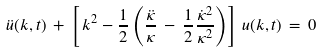Convert formula to latex. <formula><loc_0><loc_0><loc_500><loc_500>\ddot { u } ( k , t ) \, + \, \left [ \, k ^ { 2 } - { \frac { 1 } { 2 } } \left ( { \frac { \ddot { \kappa } } { \kappa } } \, - \, { \frac { 1 } { 2 } } { \frac { \dot { \kappa } ^ { 2 } } { \kappa ^ { 2 } } } \right ) \right ] \, u ( k , t ) \, = \, 0</formula> 